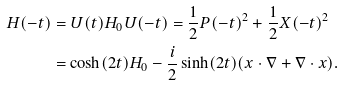Convert formula to latex. <formula><loc_0><loc_0><loc_500><loc_500>H ( - t ) & = U ( t ) H _ { 0 } U ( - t ) = \frac { 1 } { 2 } P ( - t ) ^ { 2 } + \frac { 1 } { 2 } X ( - t ) ^ { 2 } \\ & = \cosh ( 2 t ) H _ { 0 } - \frac { i } { 2 } \sinh ( 2 t ) ( x \cdot \nabla + \nabla \cdot x ) .</formula> 